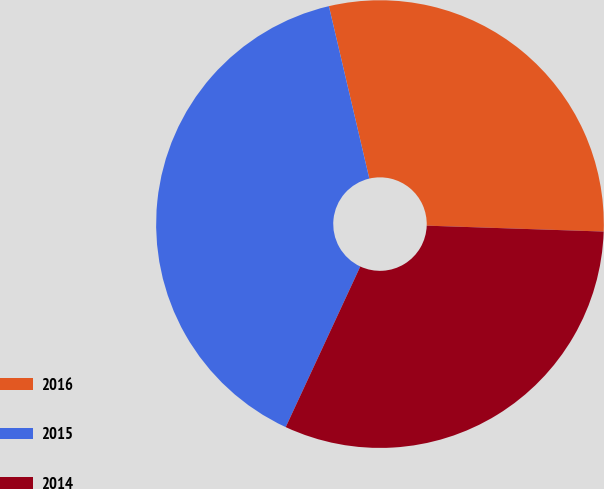Convert chart. <chart><loc_0><loc_0><loc_500><loc_500><pie_chart><fcel>2016<fcel>2015<fcel>2014<nl><fcel>29.2%<fcel>39.42%<fcel>31.39%<nl></chart> 